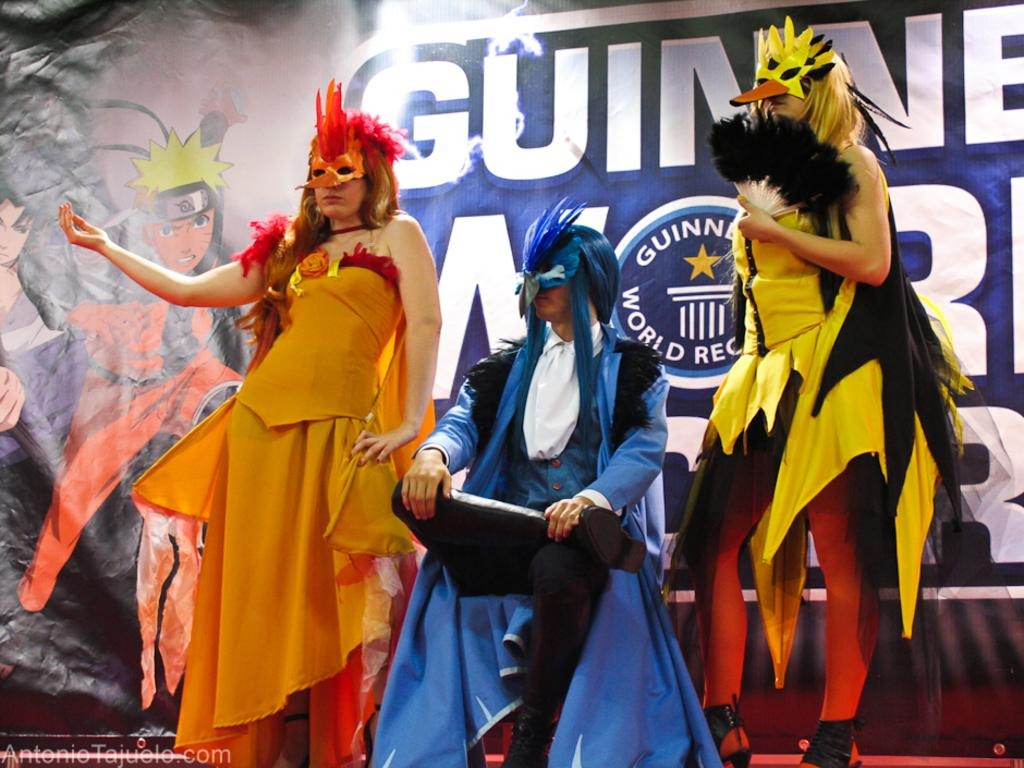How many people are in the image? There are persons in the image, but the exact number cannot be determined from the provided facts. What can be seen in the background of the image? There is a board in the background of the image. Is there any additional information about the image itself? Yes, there is a watermark on the image. Reasoning: Let' Let's think step by step in order to produce the conversation. We start by acknowledging the presence of persons in the image, but we cannot determine the exact number from the given facts. Next, we describe the background of the image, which features a board. Finally, we mention the presence of a watermark on the image, which provides additional information about the image itself. Absurd Question/Answer: How many rabbits are playing baseball in the image? There are no rabbits or baseball activity present in the image. 